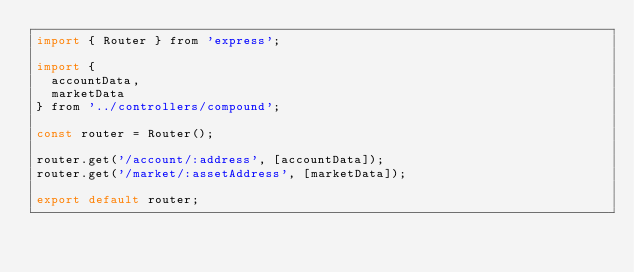Convert code to text. <code><loc_0><loc_0><loc_500><loc_500><_JavaScript_>import { Router } from 'express';

import {
  accountData,
  marketData
} from '../controllers/compound';

const router = Router();

router.get('/account/:address', [accountData]);
router.get('/market/:assetAddress', [marketData]);

export default router;
</code> 